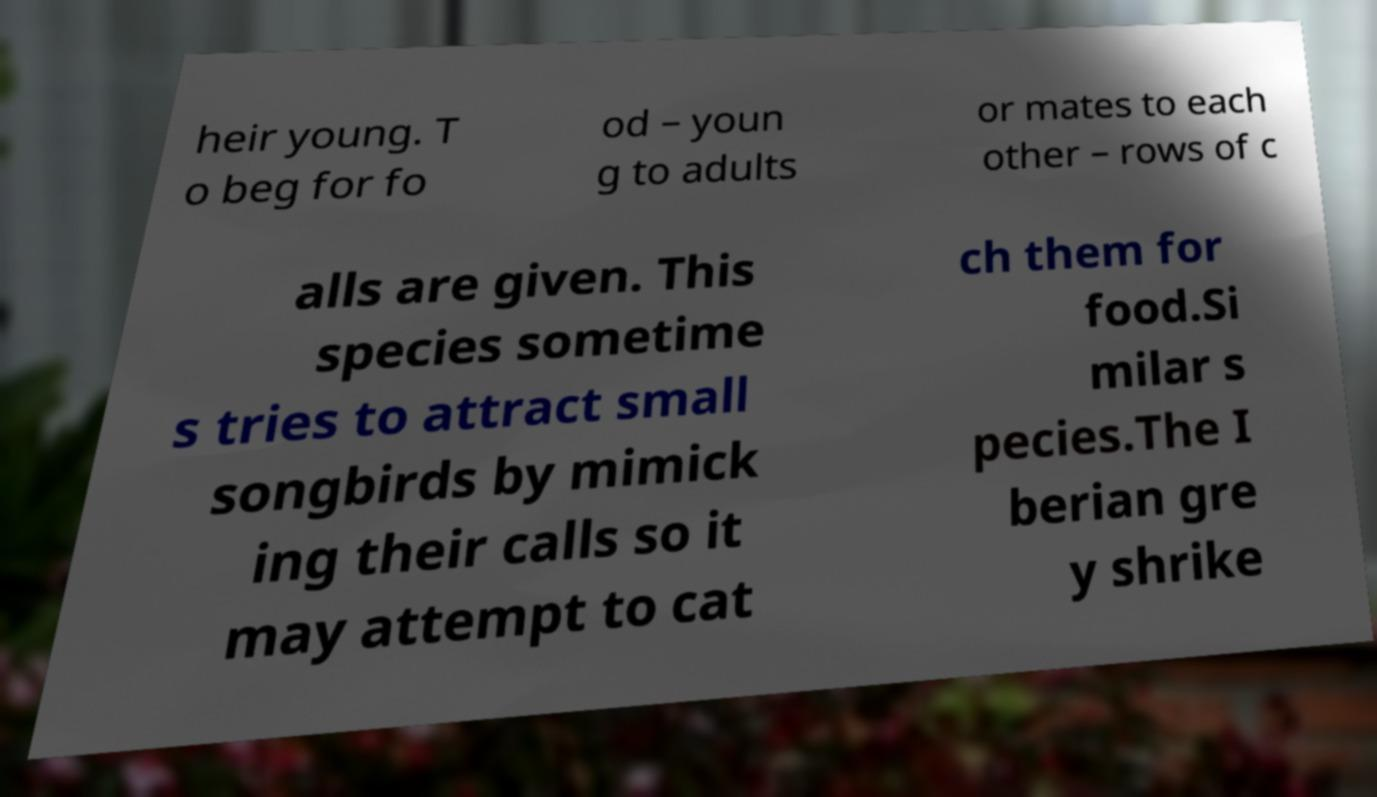What messages or text are displayed in this image? I need them in a readable, typed format. heir young. T o beg for fo od – youn g to adults or mates to each other – rows of c alls are given. This species sometime s tries to attract small songbirds by mimick ing their calls so it may attempt to cat ch them for food.Si milar s pecies.The I berian gre y shrike 